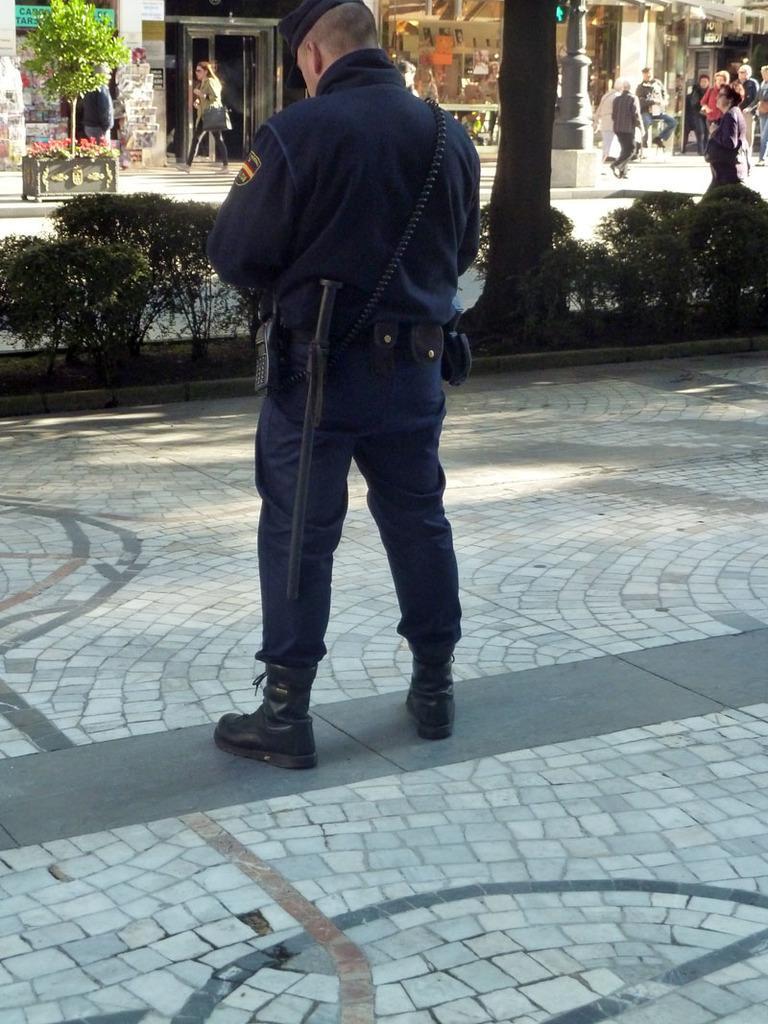Could you give a brief overview of what you see in this image? In this image we can see a man standing on the ground. We can also see some plants, the bark of a tree, a signboard with some text on it, a pillar, a group of people standing and some buildings. 